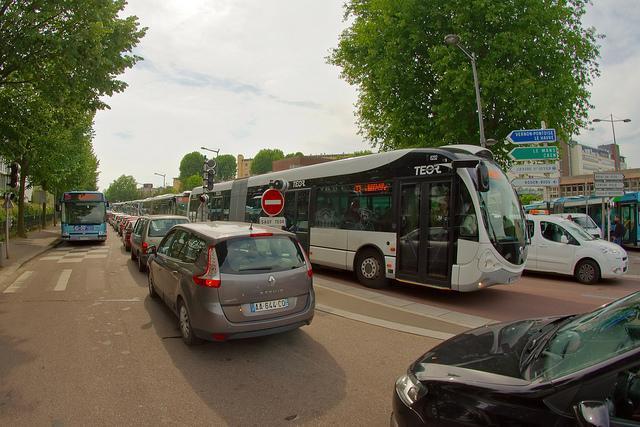How many cars are there?
Give a very brief answer. 3. How many buses are in the picture?
Give a very brief answer. 3. How many people are there?
Give a very brief answer. 0. 